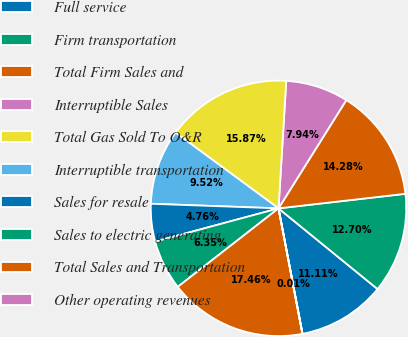Convert chart to OTSL. <chart><loc_0><loc_0><loc_500><loc_500><pie_chart><fcel>Full service<fcel>Firm transportation<fcel>Total Firm Sales and<fcel>Interruptible Sales<fcel>Total Gas Sold To O&R<fcel>Interruptible transportation<fcel>Sales for resale<fcel>Sales to electric generating<fcel>Total Sales and Transportation<fcel>Other operating revenues<nl><fcel>11.11%<fcel>12.7%<fcel>14.28%<fcel>7.94%<fcel>15.87%<fcel>9.52%<fcel>4.76%<fcel>6.35%<fcel>17.46%<fcel>0.01%<nl></chart> 